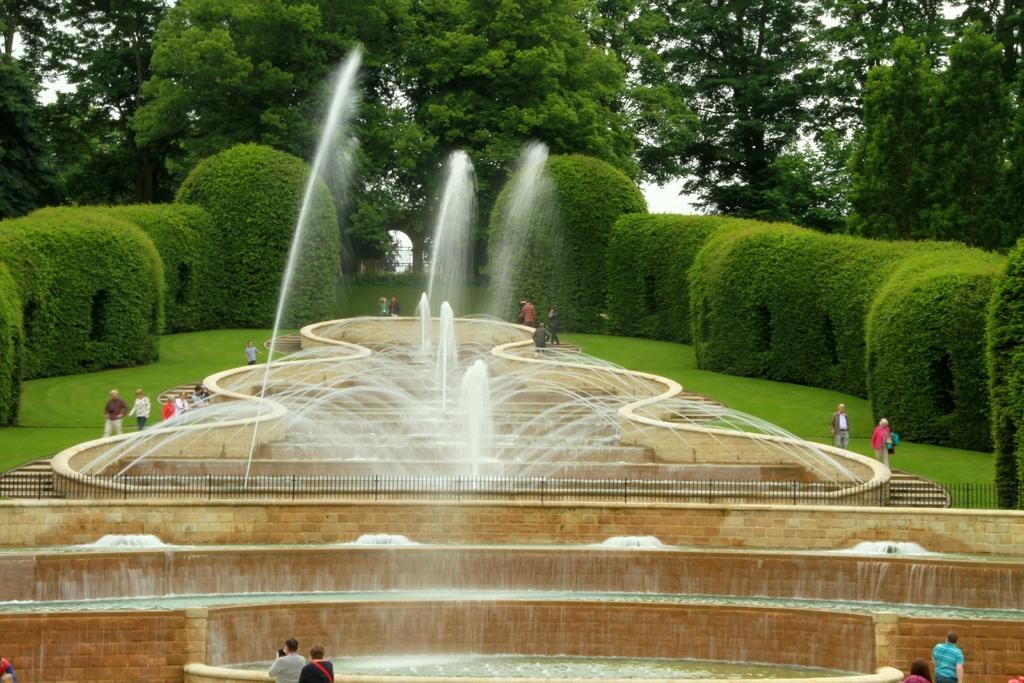Can you describe this image briefly? This is the picture of a place where we have some water fountains and around there are some people, trees, plants and some grass on the floor. 